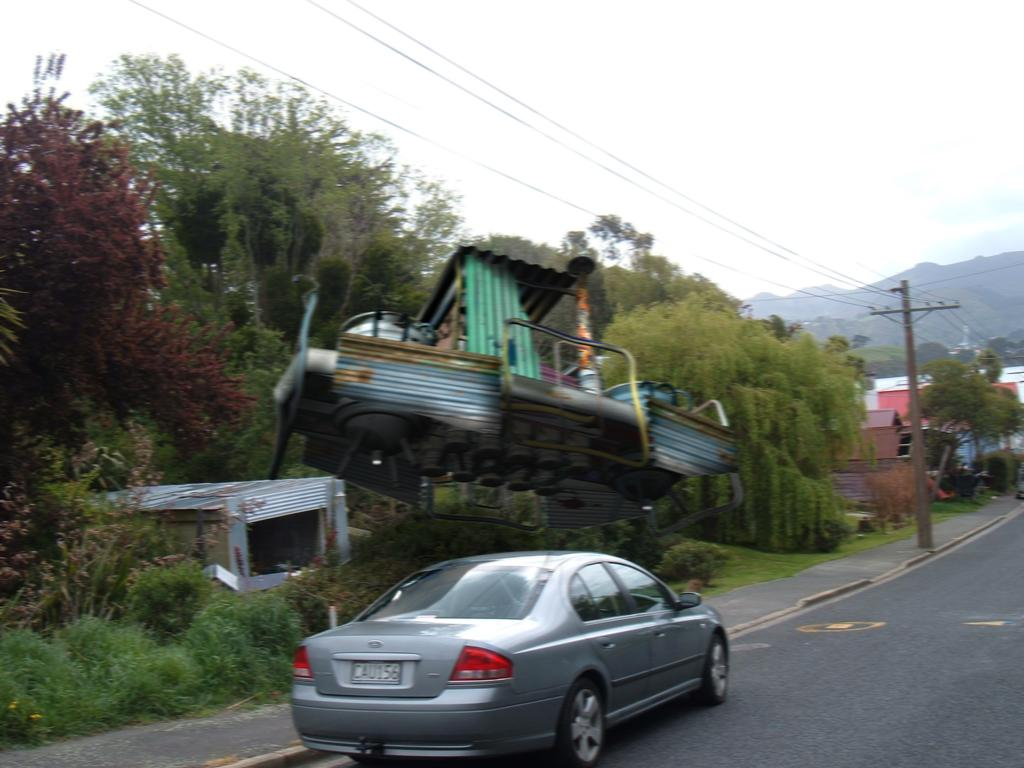What can be seen in the sky in the image? The sky with clouds is visible in the image. What type of natural formations are present in the image? There are hills in the image. What infrastructure elements can be seen in the image? Electric poles and electric cables are visible in the image. What type of structures are present in the image? There are buildings, a shed, and a motor vehicle on the road in the image. What type of vegetation can be seen in the image? Trees, creepers, and shrubs are present in the image. What type of discovery was made in the image? There is no mention of a discovery in the image; it primarily features natural and man-made elements. What type of agricultural tool is being used in the image? There is no agricultural tool, such as a plough, present in the image. 